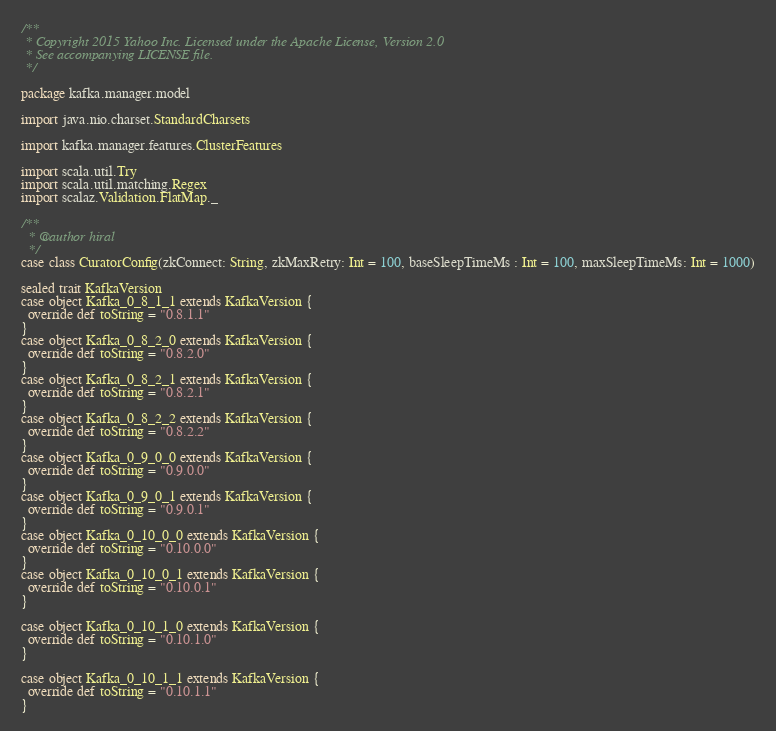<code> <loc_0><loc_0><loc_500><loc_500><_Scala_>/**
 * Copyright 2015 Yahoo Inc. Licensed under the Apache License, Version 2.0
 * See accompanying LICENSE file.
 */

package kafka.manager.model

import java.nio.charset.StandardCharsets

import kafka.manager.features.ClusterFeatures

import scala.util.Try
import scala.util.matching.Regex
import scalaz.Validation.FlatMap._

/**
  * @author hiral
  */
case class CuratorConfig(zkConnect: String, zkMaxRetry: Int = 100, baseSleepTimeMs : Int = 100, maxSleepTimeMs: Int = 1000)

sealed trait KafkaVersion
case object Kafka_0_8_1_1 extends KafkaVersion {
  override def toString = "0.8.1.1"
}
case object Kafka_0_8_2_0 extends KafkaVersion {
  override def toString = "0.8.2.0"
}
case object Kafka_0_8_2_1 extends KafkaVersion {
  override def toString = "0.8.2.1"
}
case object Kafka_0_8_2_2 extends KafkaVersion {
  override def toString = "0.8.2.2"
}
case object Kafka_0_9_0_0 extends KafkaVersion {
  override def toString = "0.9.0.0"
}
case object Kafka_0_9_0_1 extends KafkaVersion {
  override def toString = "0.9.0.1"
}
case object Kafka_0_10_0_0 extends KafkaVersion {
  override def toString = "0.10.0.0"
}
case object Kafka_0_10_0_1 extends KafkaVersion {
  override def toString = "0.10.0.1"
}

case object Kafka_0_10_1_0 extends KafkaVersion {
  override def toString = "0.10.1.0"
}

case object Kafka_0_10_1_1 extends KafkaVersion {
  override def toString = "0.10.1.1"
}
</code> 